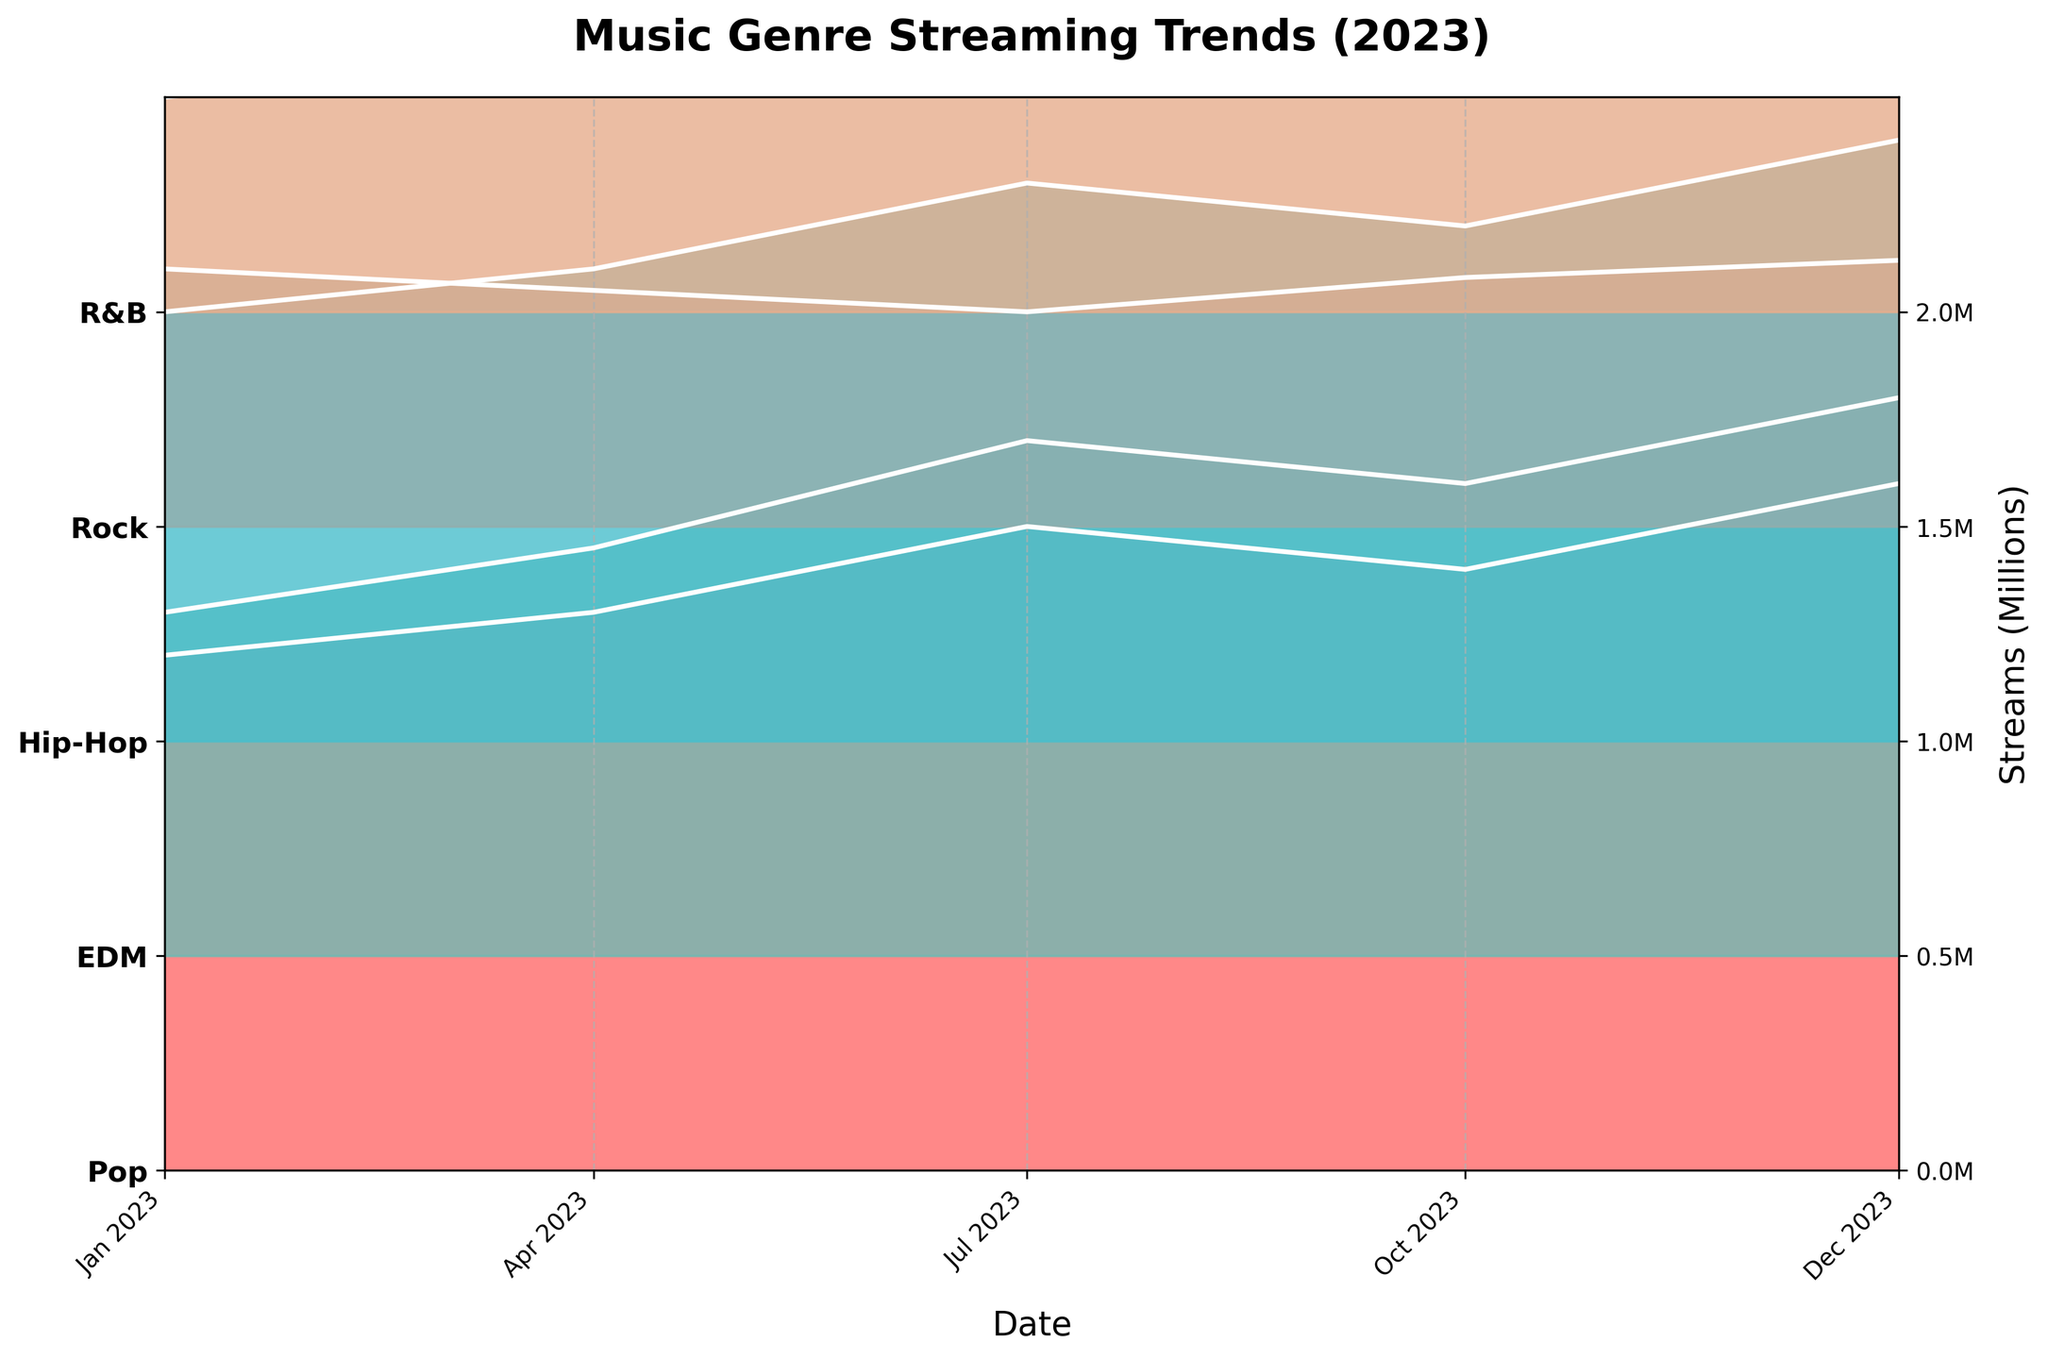What is the title of the plot? The title of the plot can be found at the top of the figure, which provides an overview of what the plot represents.
Answer: Music Genre Streaming Trends (2023) How many genres are displayed in the plot? There are distinct color bands for each genre in the plot. Counting these will give the number of genres.
Answer: 5 Which genre has the highest streaming numbers at the beginning of the year? Look at the leftmost part of the plot (January 1st) and identify the genre with the highest peak.
Answer: Pop In which month did the EDM genre reach its highest streaming numbers? Trace the EDM genre across the months and find the peak. Compare each peak for EDM across different months.
Answer: December Which genre saw the largest increase in streaming numbers from January to July? Examine the height difference between the January and July peaks for each genre, and identify the one with the largest increase.
Answer: EDM What is the average streaming count in millions for the Hip-Hop genre throughout the year? Sum the Hip-Hop streaming numbers for all dates (1.0M + 1.1M + 1.3M + 1.2M + 1.4M) and divide by the number of data points (5).
Answer: 1.2M How do the streaming numbers for Rock compare in July to October? Look at the heights of the Rock genre in July and October to compare the numbers.
Answer: July is lower than October Which genre had the most consistent streaming numbers across the year? Observe the plot lines for each genre across all months and identify the one that remains relatively flat without major peaks or troughs.
Answer: Rock Which time period saw the biggest increase in streaming numbers for R&B? Compare the differences in heights between adjacent months for R&B, focusing on the maximum difference.
Answer: January to April Overall, during which month did the streaming numbers for all genres collectively peak the highest? Assess the combined height of all genres for each month and determine when the total sum is the greatest.
Answer: December 